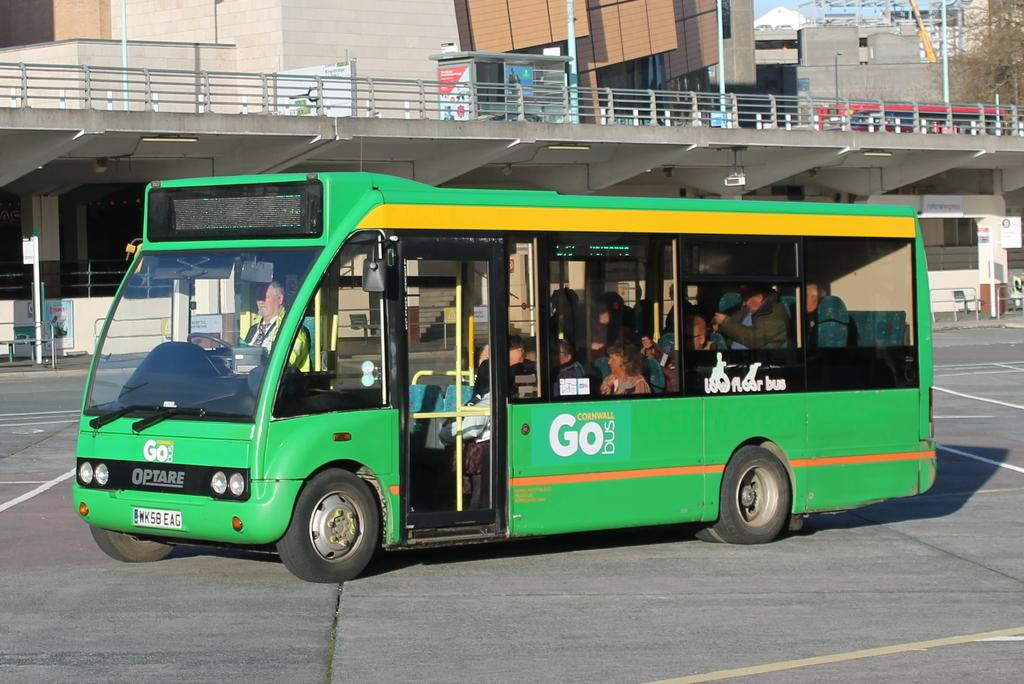<image>
Provide a brief description of the given image. A green Optare bus sits filled with people, the words Go Bus are written on its side. 